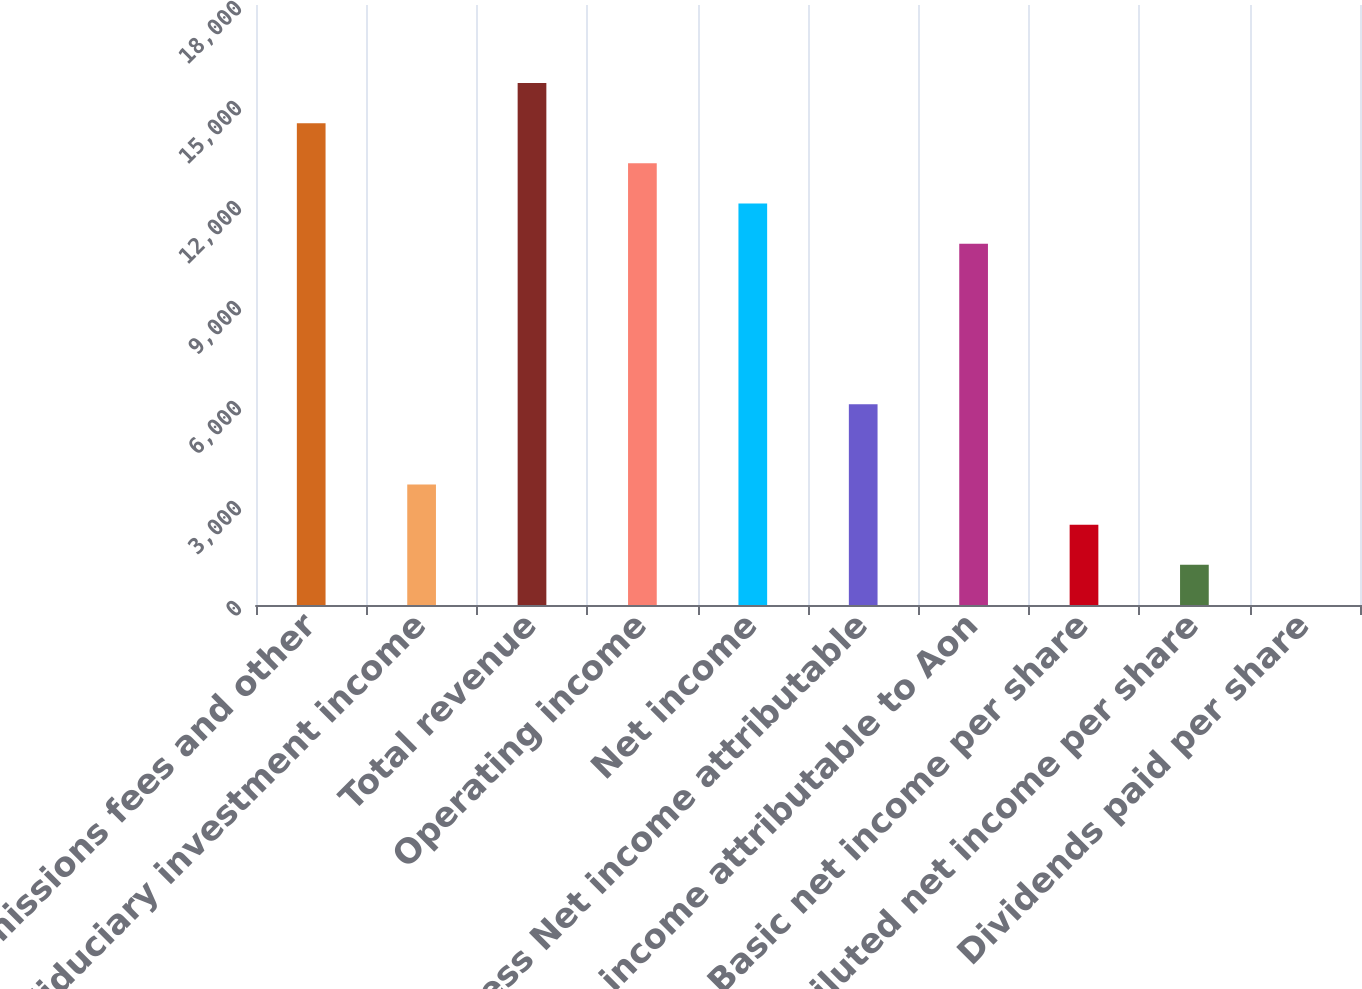Convert chart. <chart><loc_0><loc_0><loc_500><loc_500><bar_chart><fcel>Commissions fees and other<fcel>Fiduciary investment income<fcel>Total revenue<fcel>Operating income<fcel>Net income<fcel>Less Net income attributable<fcel>Net income attributable to Aon<fcel>Basic net income per share<fcel>Diluted net income per share<fcel>Dividends paid per share<nl><fcel>14453.8<fcel>3614.15<fcel>15658.2<fcel>13249.4<fcel>12045<fcel>6022.97<fcel>10840.6<fcel>2409.74<fcel>1205.33<fcel>0.92<nl></chart> 